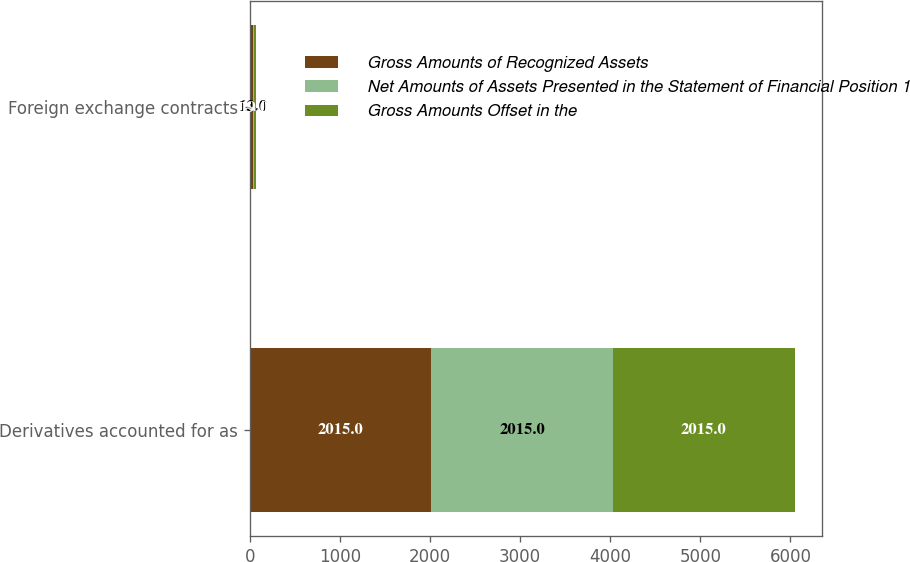Convert chart. <chart><loc_0><loc_0><loc_500><loc_500><stacked_bar_chart><ecel><fcel>Derivatives accounted for as<fcel>Foreign exchange contracts<nl><fcel>Gross Amounts of Recognized Assets<fcel>2015<fcel>32<nl><fcel>Net Amounts of Assets Presented in the Statement of Financial Position 1<fcel>2015<fcel>13<nl><fcel>Gross Amounts Offset in the<fcel>2015<fcel>19<nl></chart> 